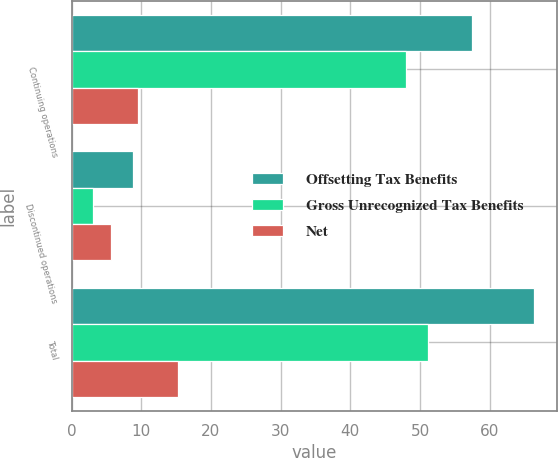<chart> <loc_0><loc_0><loc_500><loc_500><stacked_bar_chart><ecel><fcel>Continuing operations<fcel>Discontinued operations<fcel>Total<nl><fcel>Offsetting Tax Benefits<fcel>57.5<fcel>8.8<fcel>66.3<nl><fcel>Gross Unrecognized Tax Benefits<fcel>48<fcel>3.1<fcel>51.1<nl><fcel>Net<fcel>9.5<fcel>5.7<fcel>15.2<nl></chart> 